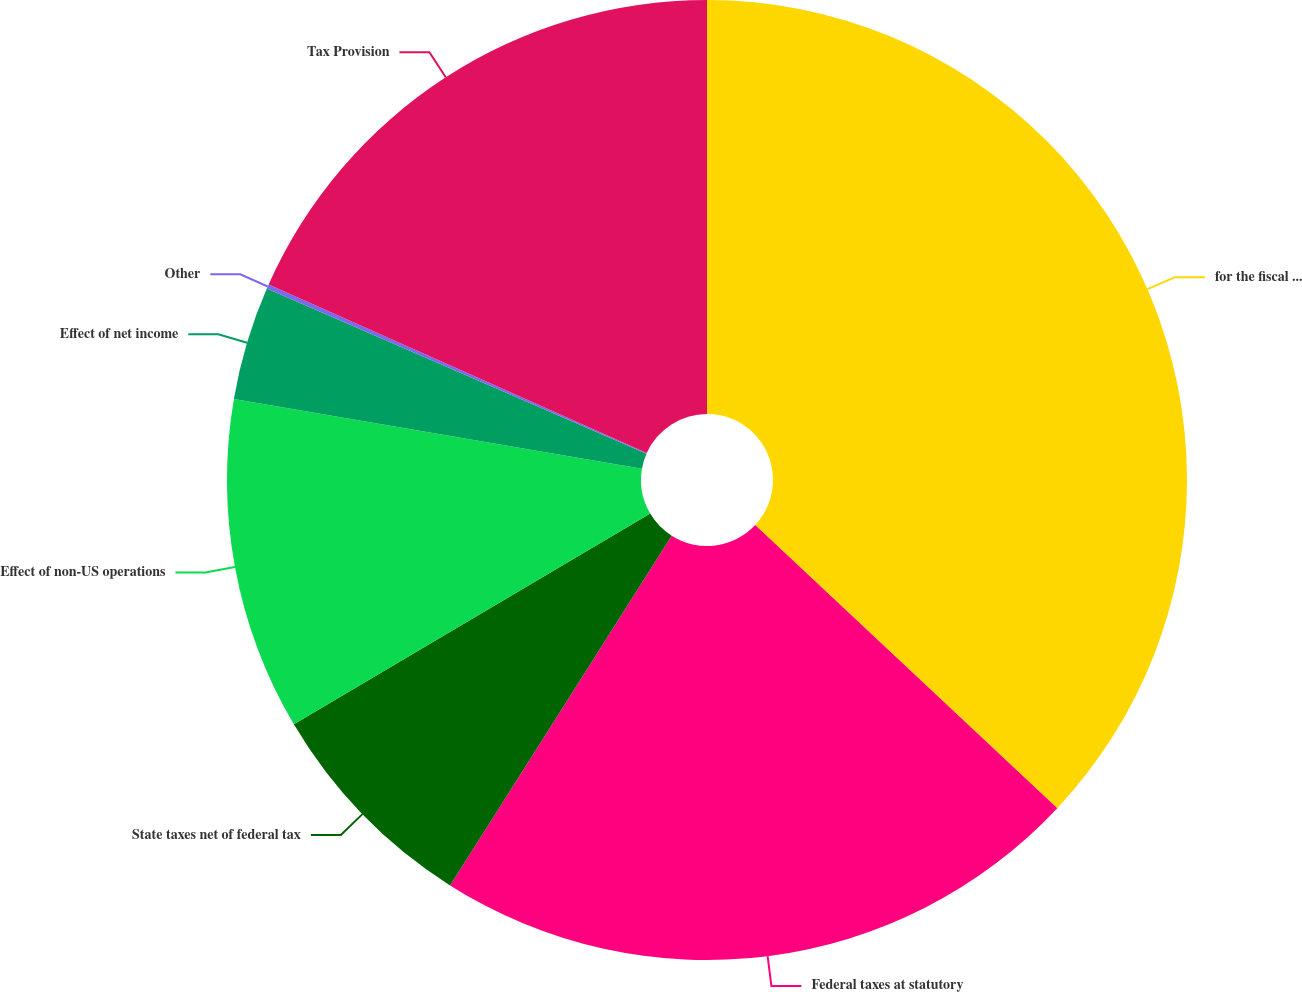Convert chart to OTSL. <chart><loc_0><loc_0><loc_500><loc_500><pie_chart><fcel>for the fiscal years ended<fcel>Federal taxes at statutory<fcel>State taxes net of federal tax<fcel>Effect of non-US operations<fcel>Effect of net income<fcel>Other<fcel>Tax Provision<nl><fcel>36.98%<fcel>22.01%<fcel>7.51%<fcel>11.2%<fcel>3.83%<fcel>0.15%<fcel>18.32%<nl></chart> 